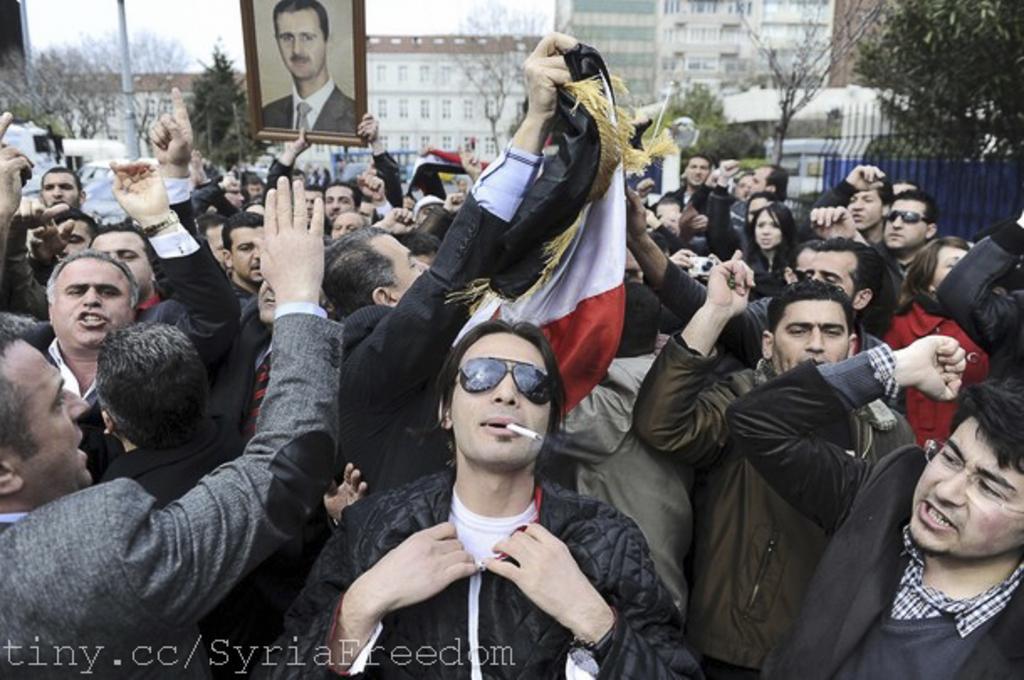Can you describe this image briefly? In the image we can see there are lot of people standing and they are holding photo frame, flags in their hand. Behind there are trees and there are buildings. 